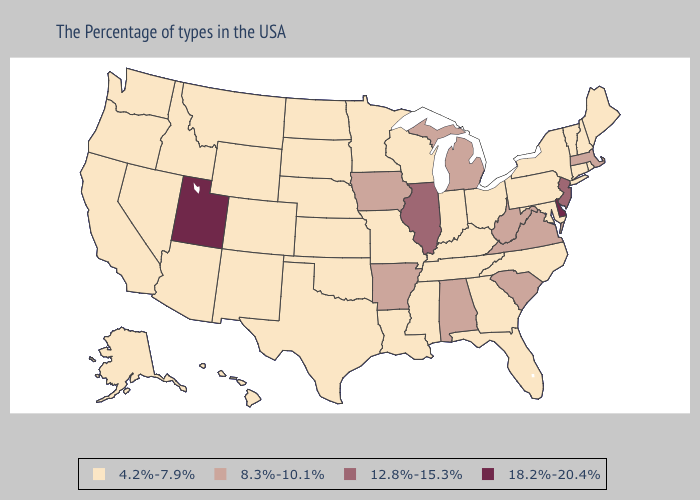Which states have the highest value in the USA?
Short answer required. Delaware, Utah. Name the states that have a value in the range 18.2%-20.4%?
Be succinct. Delaware, Utah. What is the highest value in the South ?
Write a very short answer. 18.2%-20.4%. Name the states that have a value in the range 18.2%-20.4%?
Answer briefly. Delaware, Utah. Among the states that border Virginia , which have the highest value?
Quick response, please. West Virginia. What is the lowest value in states that border Oklahoma?
Answer briefly. 4.2%-7.9%. Does North Carolina have a lower value than Washington?
Quick response, please. No. Does the first symbol in the legend represent the smallest category?
Give a very brief answer. Yes. What is the value of New Hampshire?
Write a very short answer. 4.2%-7.9%. Which states have the highest value in the USA?
Give a very brief answer. Delaware, Utah. Which states have the lowest value in the USA?
Keep it brief. Maine, Rhode Island, New Hampshire, Vermont, Connecticut, New York, Maryland, Pennsylvania, North Carolina, Ohio, Florida, Georgia, Kentucky, Indiana, Tennessee, Wisconsin, Mississippi, Louisiana, Missouri, Minnesota, Kansas, Nebraska, Oklahoma, Texas, South Dakota, North Dakota, Wyoming, Colorado, New Mexico, Montana, Arizona, Idaho, Nevada, California, Washington, Oregon, Alaska, Hawaii. Does Maine have a lower value than Hawaii?
Short answer required. No. Does Utah have the highest value in the USA?
Concise answer only. Yes. Does New Mexico have a higher value than Tennessee?
Keep it brief. No. What is the value of California?
Be succinct. 4.2%-7.9%. 